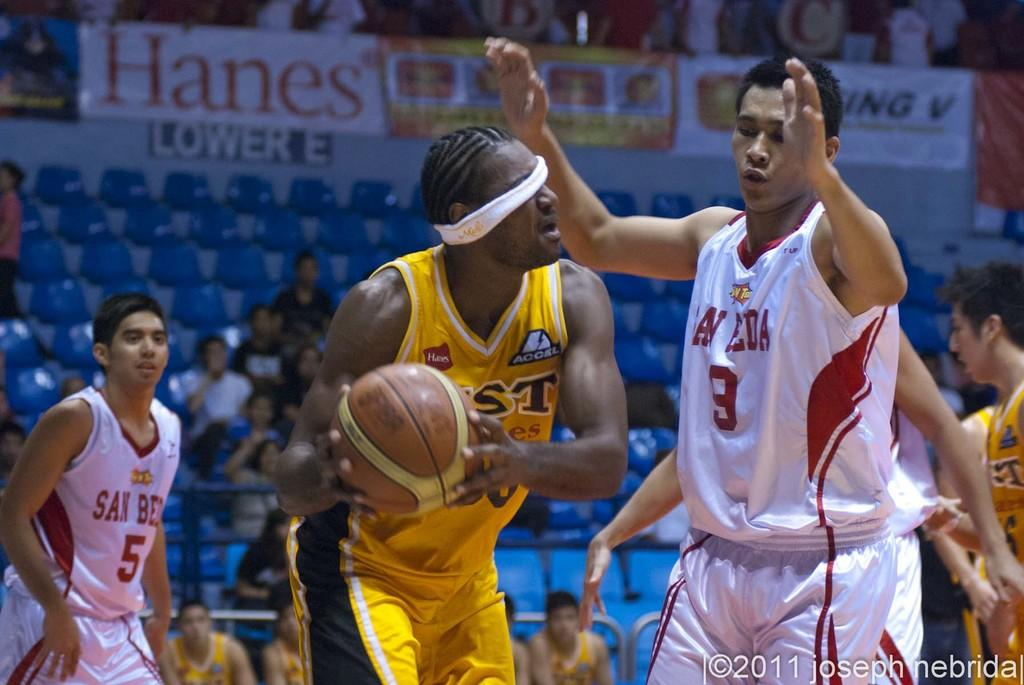<image>
Create a compact narrative representing the image presented. basketball player with headband blocking his eyes and hanes sign above section lower E 